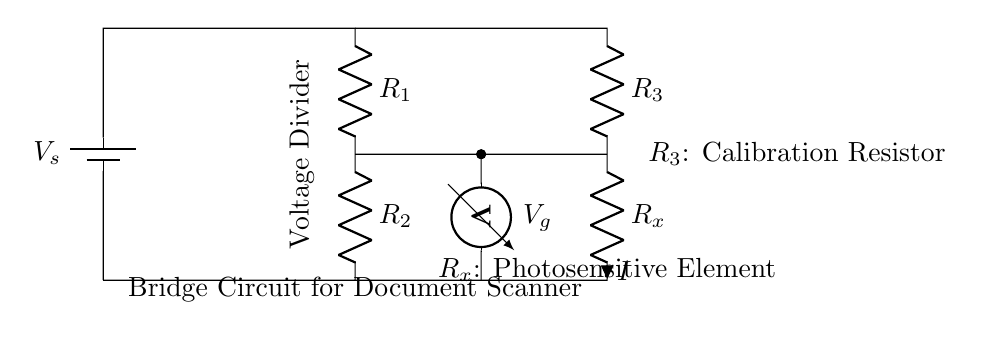What is the supply voltage in this circuit? The circuit diagram specifies a voltage source labeled V_s, which represents the supply voltage for the circuit. The exact value is not provided in the diagram.
Answer: V_s What are the resistances in this bridge circuit? The circuit shows three resistors, labeled R_1, R_2, and R_3, along with one variable resistor labeled R_x which represents the photosensitive element.
Answer: R_1, R_2, R_3, R_x What is the purpose of the voltmeter in this circuit? The voltmeter is connected across the junction where R_2 and R_3 meet and measures the voltage difference at that point, indicating the balance of the bridge circuit.
Answer: Measure voltage How many resistors are in the bridge circuit? The diagram features four resistors: R_1, R_2, R_3, and R_x. R_x is specifically the photosensitive element, while the other three are fixed resistors.
Answer: Four What does a balanced bridge condition imply for R_x? A balanced bridge condition occurs when the voltage across the voltmeter is zero, indicating that the ratio of the resistances (R_1/R_2 = R_3/R_x) is satisfied, allowing for accurate measurement of R_x.
Answer: Zero voltage What component represents the photosensitive element? The component labeled R_x represents the photosensitive element in the document scanner, which is the resistance being measured in this bridge circuit.
Answer: R_x Which resistor can be adjusted for calibration? The resistor labeled R_3 serves as the calibration resistor within the bridge circuit and can be adjusted to achieve balance in the circuit for accurate resistance measurement of R_x.
Answer: R_3 